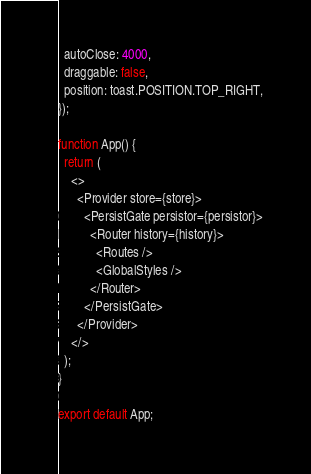<code> <loc_0><loc_0><loc_500><loc_500><_JavaScript_>  autoClose: 4000,
  draggable: false,
  position: toast.POSITION.TOP_RIGHT,
});

function App() {
  return (
    <>
      <Provider store={store}>
        <PersistGate persistor={persistor}>
          <Router history={history}>
            <Routes />
            <GlobalStyles />
          </Router>
        </PersistGate>
      </Provider>
    </>
  );
}

export default App;
</code> 